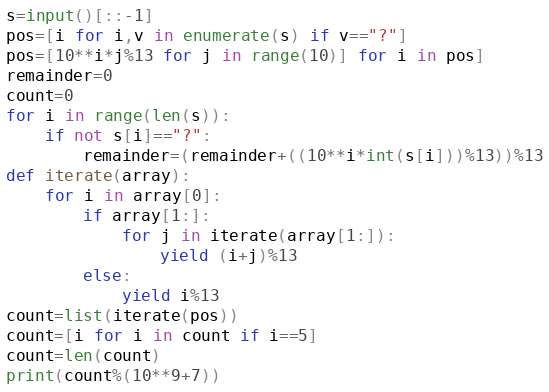<code> <loc_0><loc_0><loc_500><loc_500><_Python_>s=input()[::-1]
pos=[i for i,v in enumerate(s) if v=="?"]
pos=[10**i*j%13 for j in range(10)] for i in pos]
remainder=0
count=0
for i in range(len(s)):
    if not s[i]=="?":
        remainder=(remainder+((10**i*int(s[i]))%13))%13
def iterate(array):
    for i in array[0]:
        if array[1:]:
            for j in iterate(array[1:]):
                yield (i+j)%13
        else:
            yield i%13
count=list(iterate(pos))
count=[i for i in count if i==5]
count=len(count)
print(count%(10**9+7))
</code> 